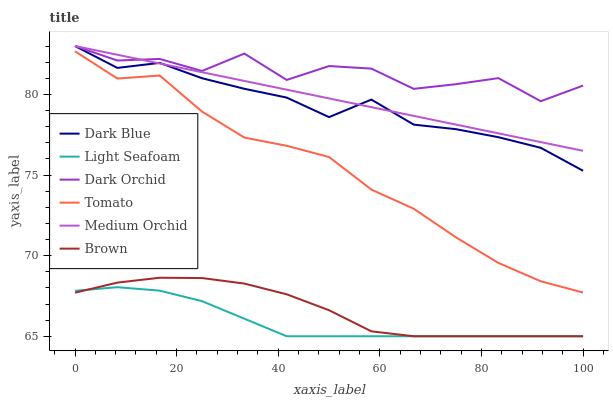Does Brown have the minimum area under the curve?
Answer yes or no. No. Does Brown have the maximum area under the curve?
Answer yes or no. No. Is Brown the smoothest?
Answer yes or no. No. Is Brown the roughest?
Answer yes or no. No. Does Medium Orchid have the lowest value?
Answer yes or no. No. Does Brown have the highest value?
Answer yes or no. No. Is Light Seafoam less than Dark Blue?
Answer yes or no. Yes. Is Dark Orchid greater than Tomato?
Answer yes or no. Yes. Does Light Seafoam intersect Dark Blue?
Answer yes or no. No. 